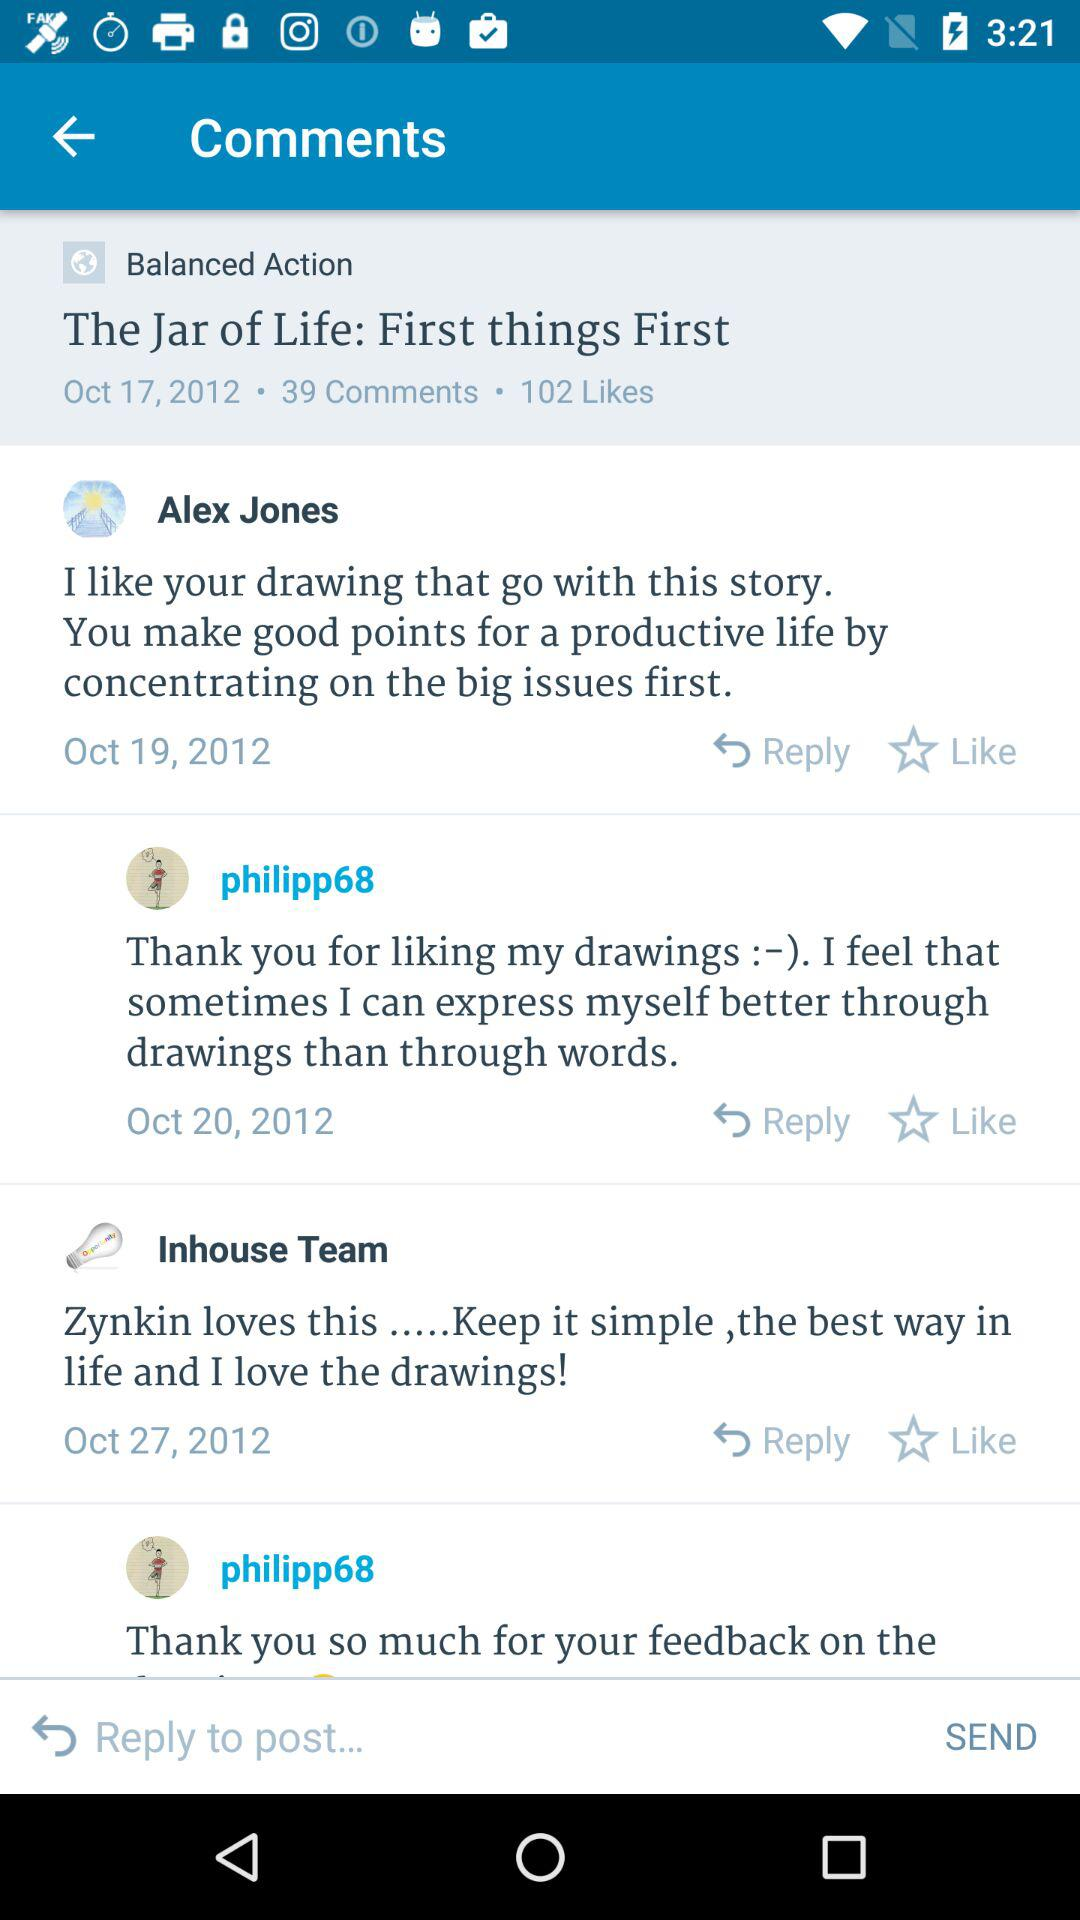How many comments are there on this post?
Answer the question using a single word or phrase. 39 